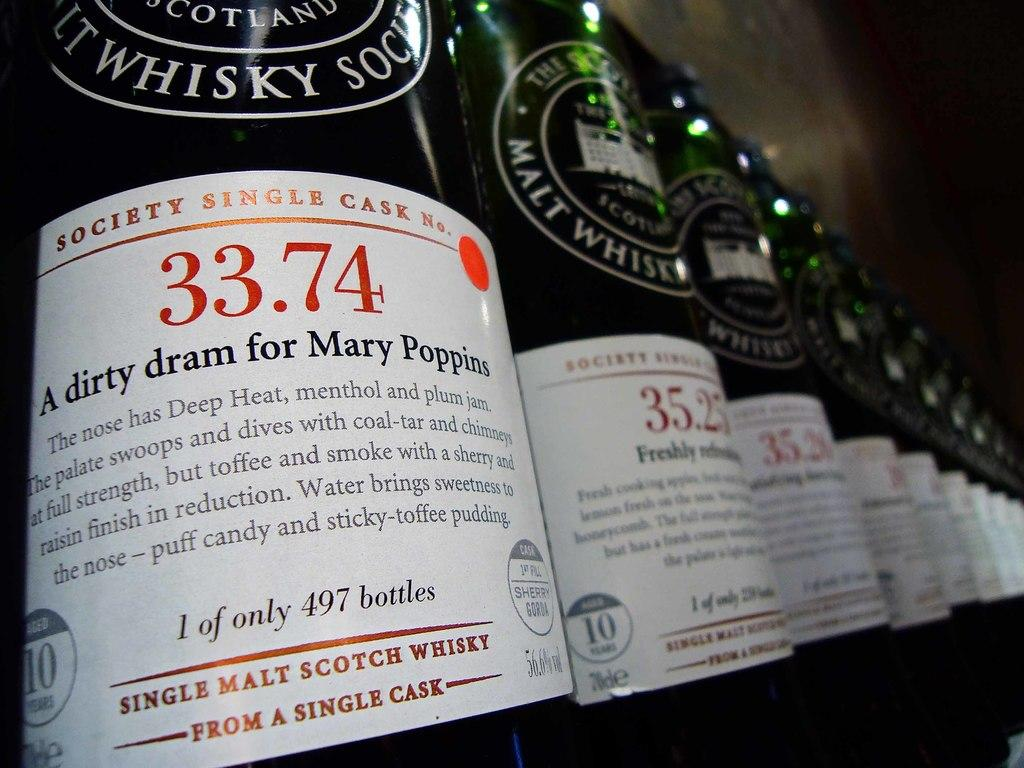<image>
Offer a succinct explanation of the picture presented. the name Mary Poppins that is on a bottle 